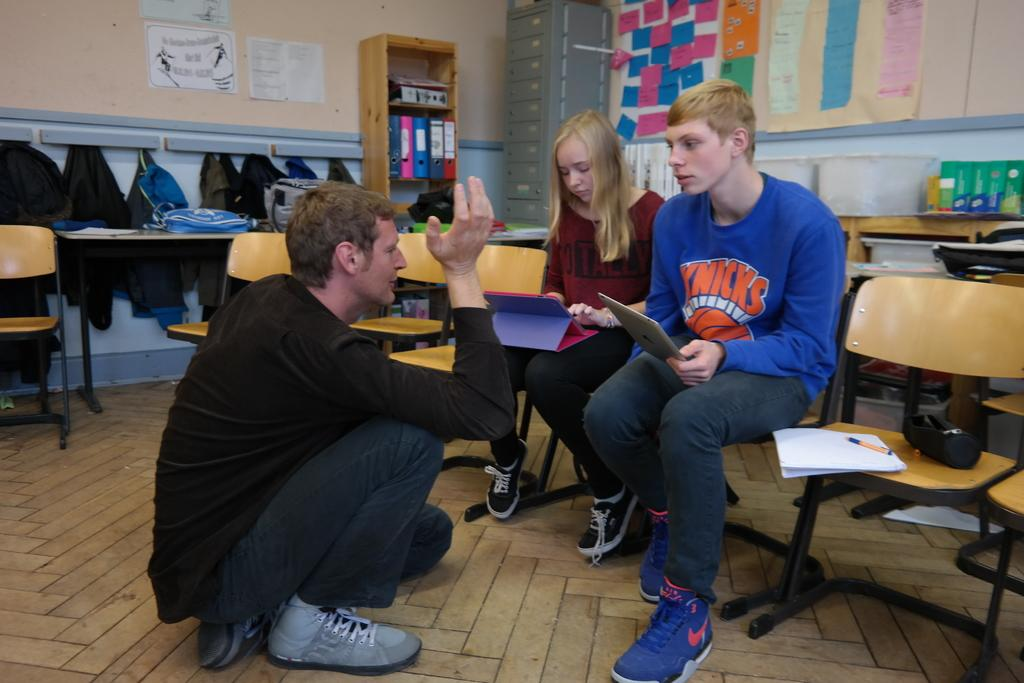How many people are in the image? There are three individuals in the image: two men and a woman. What are the three individuals doing in the image? The three individuals are sitting. What furniture is present in the image? There are chairs in the image. What else can be seen in the image besides the people and chairs? There are clothes visible in the image. What type of band is playing in the image? There is no band present in the image. Can you describe the elbow of the woman in the image? The image does not show the elbows of the individuals, only their sitting positions. 